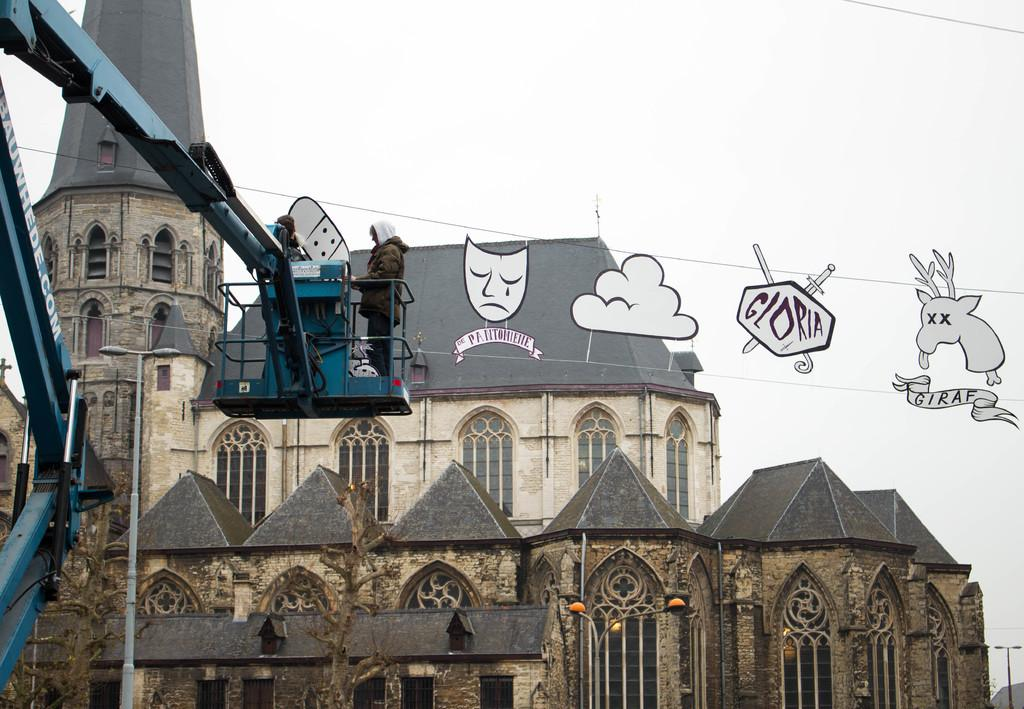What is the main subject in the center of the image? There is a building in the center of the image. Can you describe any activity or people in the image? Yes, there are people standing in a crane. What type of quill is being used by the sisters in the image? There are no sisters or quills present in the image. 